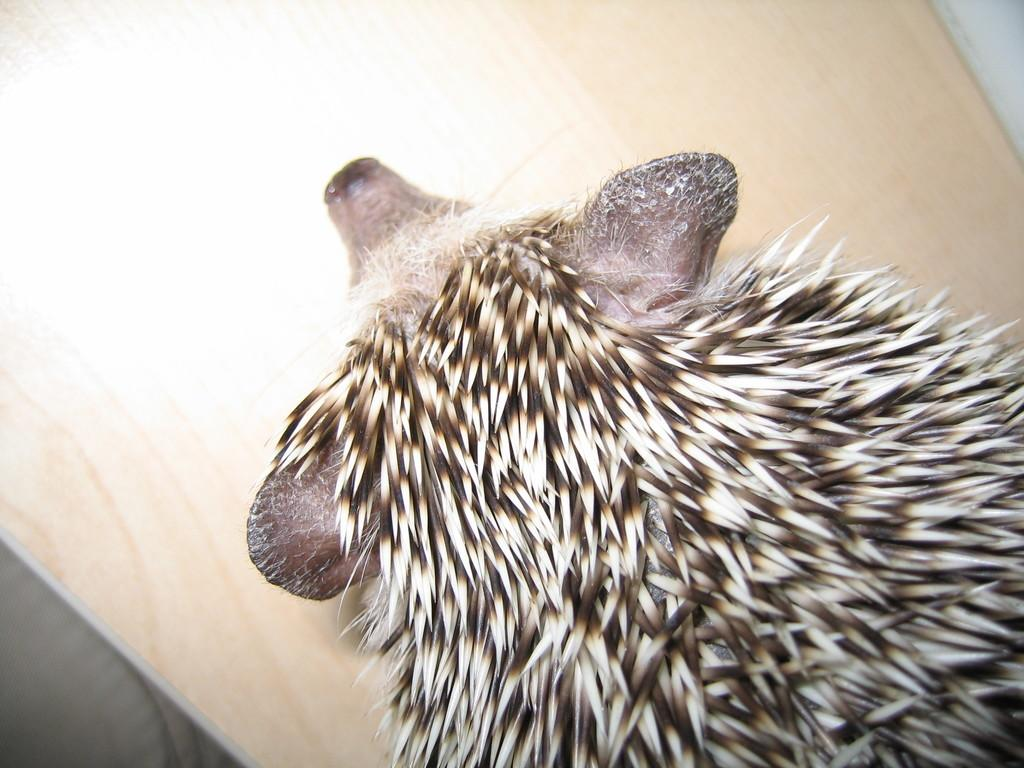What type of animal is present in the image? There is an animal in the image. Can you describe the color pattern of the animal? The animal is in brown and white color. What is the color of the background in the image? The background of the image is brown. What type of transport is visible in the image? There is no transport visible in the image; it features an animal in a brown and white color with a brown background. What is the position of the boundary in the image? There is no boundary present in the image. 